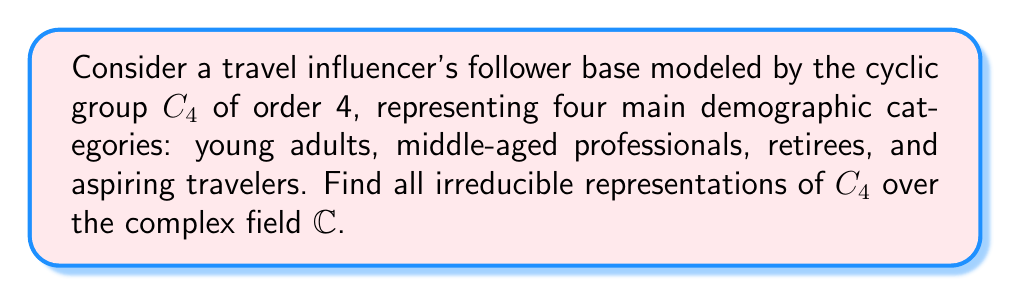Could you help me with this problem? 1) First, recall that for a cyclic group $C_n$, there are exactly $n$ irreducible representations over $\mathbb{C}$, each of dimension 1.

2) Let $g$ be a generator of $C_4$. Then $C_4 = \{e, g, g^2, g^3\}$.

3) The irreducible representations are given by:

   $\rho_k: C_4 \to \mathbb{C}^*$
   $\rho_k(g^j) = e^{2\pi i jk/4}$ for $k = 0, 1, 2, 3$

4) Let's compute these representations explicitly:

   For $k = 0$: $\rho_0(g^j) = 1$ for all $j$ (trivial representation)
   
   For $k = 1$: $\rho_1(g^j) = i^j$
   
   For $k = 2$: $\rho_2(g^j) = (-1)^j$
   
   For $k = 3$: $\rho_3(g^j) = (-i)^j$

5) We can represent these as matrices (though they're 1x1):

   $\rho_0: e \mapsto [1], g \mapsto [1], g^2 \mapsto [1], g^3 \mapsto [1]$
   
   $\rho_1: e \mapsto [1], g \mapsto [i], g^2 \mapsto [-1], g^3 \mapsto [-i]$
   
   $\rho_2: e \mapsto [1], g \mapsto [-1], g^2 \mapsto [1], g^3 \mapsto [-1]$
   
   $\rho_3: e \mapsto [1], g \mapsto [-i], g^2 \mapsto [-1], g^3 \mapsto [i]$

These four representations are all the irreducible representations of $C_4$ over $\mathbb{C}$.
Answer: $\rho_0, \rho_1, \rho_2, \rho_3$ where $\rho_k(g^j) = e^{2\pi i jk/4}$ for $k = 0, 1, 2, 3$ 